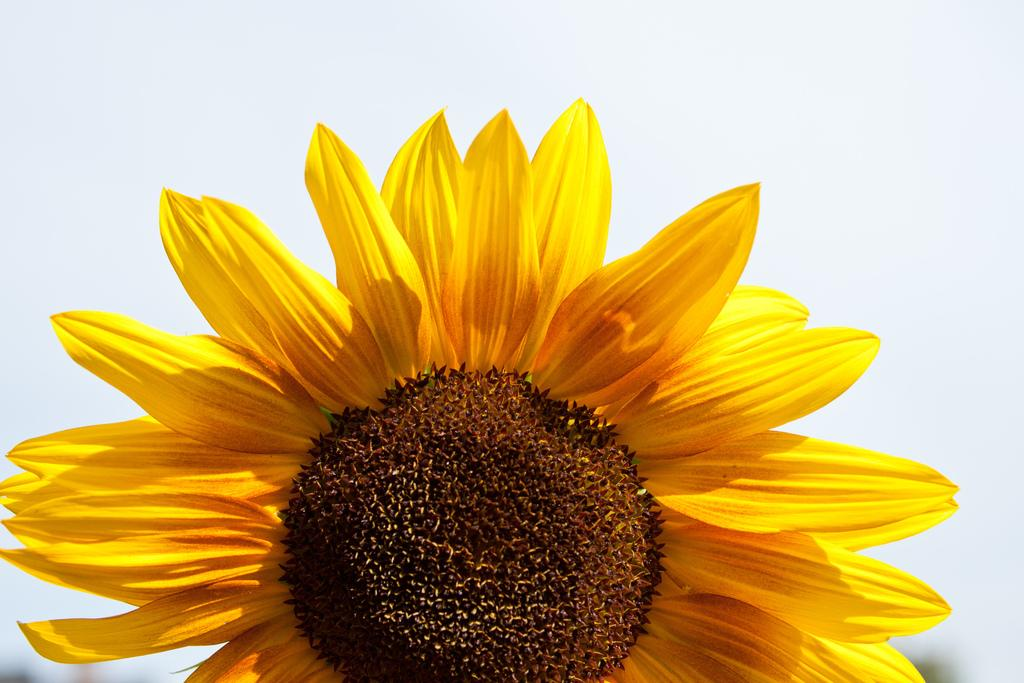What is the main subject of the image? There is a flower in the image. What can be seen in the background of the image? The sky is visible behind the flower in the image. What type of texture does the minister's robe have in the image? There is no minister or robe present in the image; it features a flower and the sky. What type of desk is visible in the image? There is no desk present in the image; it features a flower and the sky. 